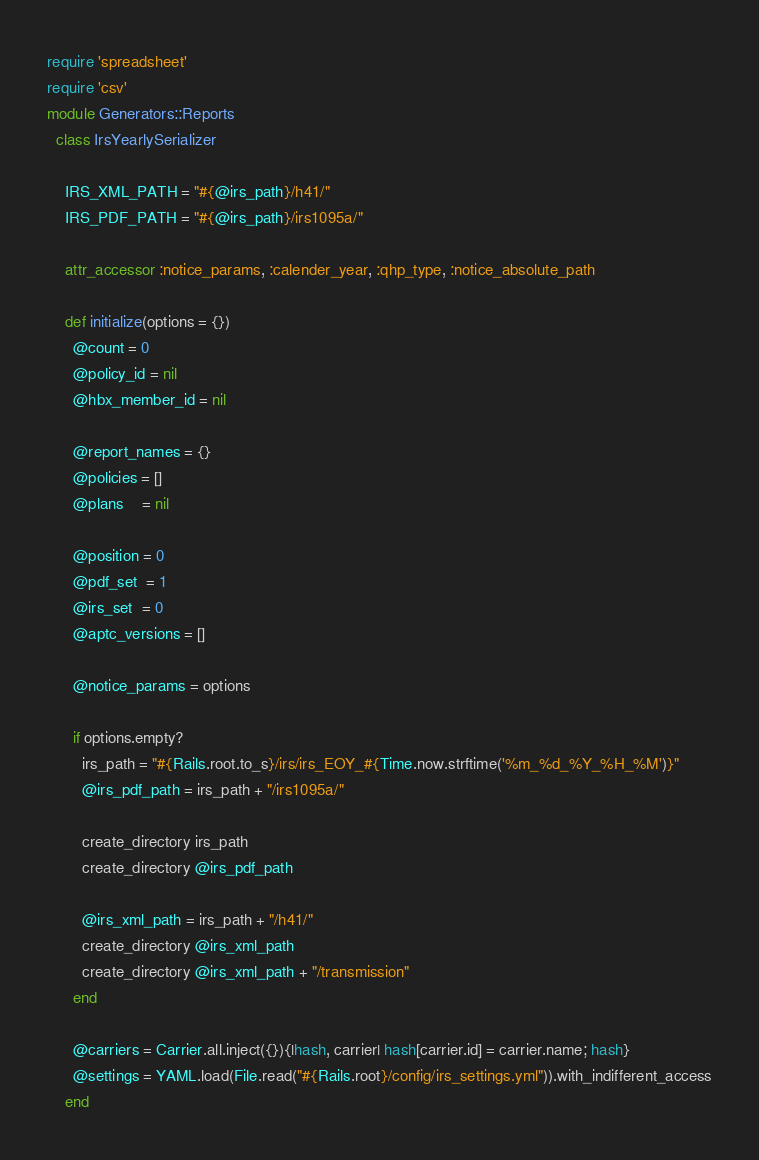Convert code to text. <code><loc_0><loc_0><loc_500><loc_500><_Ruby_>require 'spreadsheet'
require 'csv'
module Generators::Reports  
  class IrsYearlySerializer

    IRS_XML_PATH = "#{@irs_path}/h41/"
    IRS_PDF_PATH = "#{@irs_path}/irs1095a/"

    attr_accessor :notice_params, :calender_year, :qhp_type, :notice_absolute_path

    def initialize(options = {})
      @count = 0
      @policy_id = nil
      @hbx_member_id = nil

      @report_names = {}
      @policies = []
      @plans    = nil

      @position = 0
      @pdf_set  = 1
      @irs_set  = 0
      @aptc_versions = []

      @notice_params = options

      if options.empty?
        irs_path = "#{Rails.root.to_s}/irs/irs_EOY_#{Time.now.strftime('%m_%d_%Y_%H_%M')}"
        @irs_pdf_path = irs_path + "/irs1095a/"

        create_directory irs_path
        create_directory @irs_pdf_path

        @irs_xml_path = irs_path + "/h41/"
        create_directory @irs_xml_path
        create_directory @irs_xml_path + "/transmission"
      end

      @carriers = Carrier.all.inject({}){|hash, carrier| hash[carrier.id] = carrier.name; hash}
      @settings = YAML.load(File.read("#{Rails.root}/config/irs_settings.yml")).with_indifferent_access
    end

</code> 